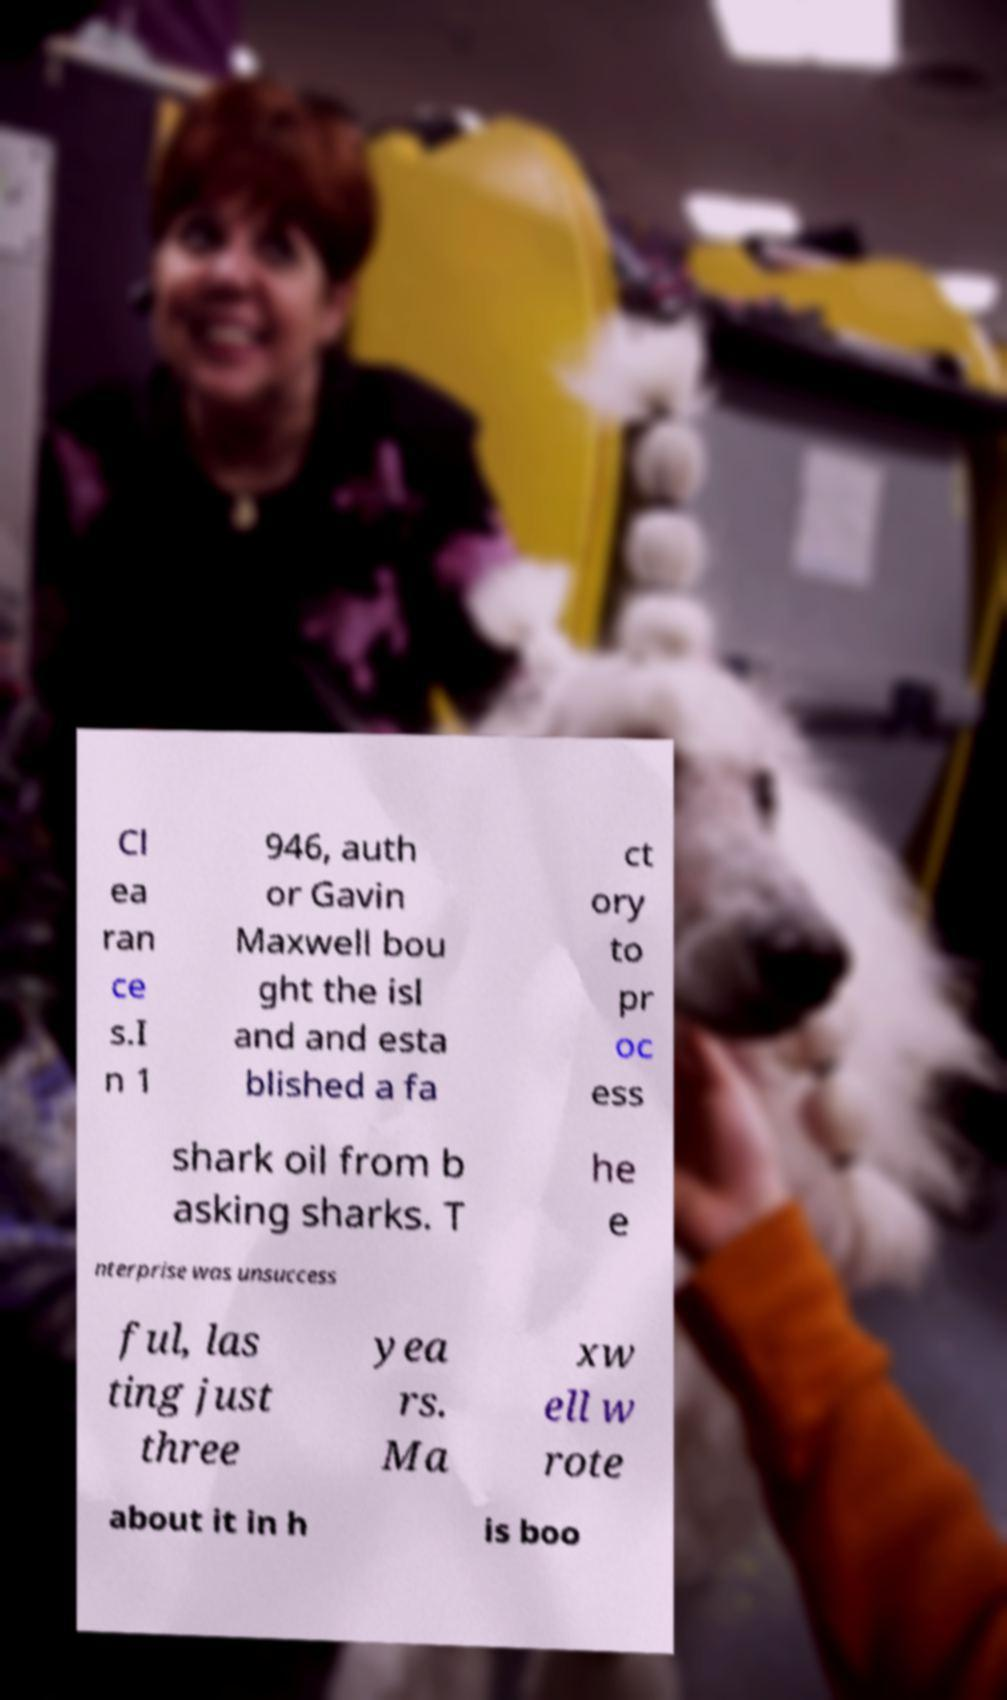Can you read and provide the text displayed in the image?This photo seems to have some interesting text. Can you extract and type it out for me? Cl ea ran ce s.I n 1 946, auth or Gavin Maxwell bou ght the isl and and esta blished a fa ct ory to pr oc ess shark oil from b asking sharks. T he e nterprise was unsuccess ful, las ting just three yea rs. Ma xw ell w rote about it in h is boo 